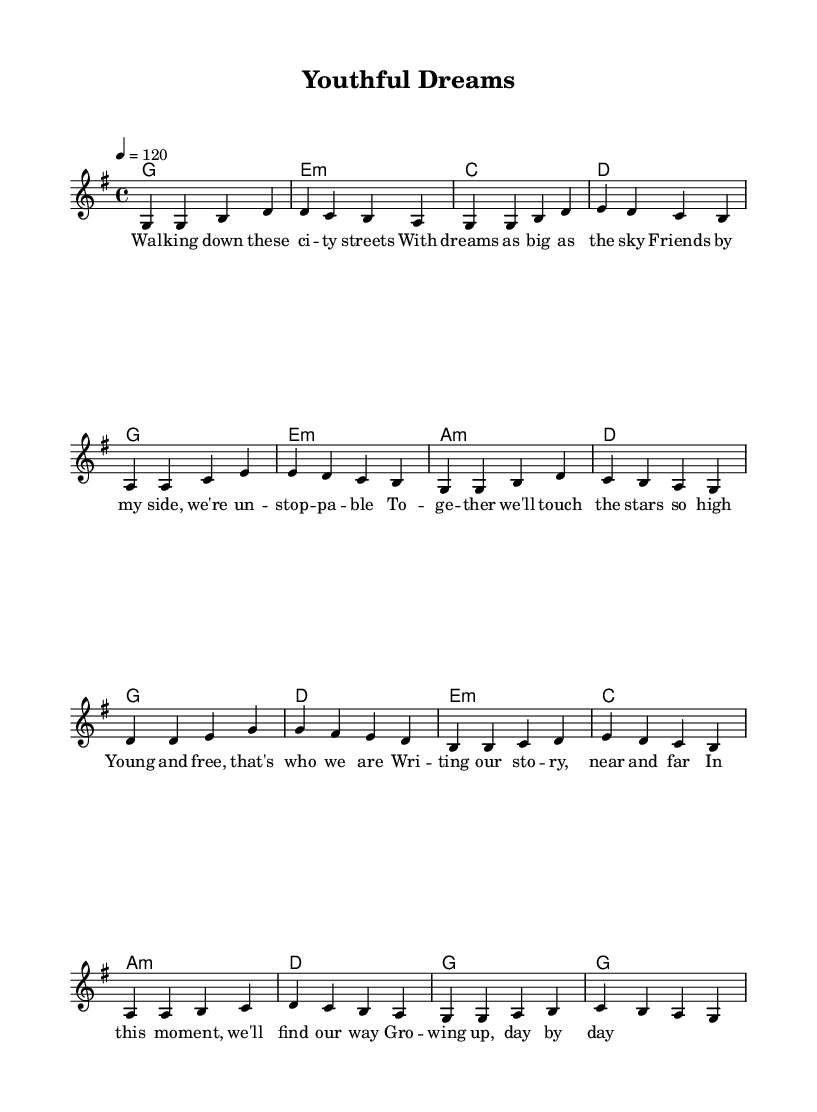What is the key signature of this music? The key signature can be found in the first measure or line of the music notation. It shows a G major key, which has one sharp (F#).
Answer: G major What is the time signature of this piece? The time signature is found at the beginning of the music score, indicating how many beats are in each measure. Here, it shows a 4 over 4, meaning there are four quarter note beats per measure.
Answer: 4/4 What is the tempo marking given for the music? The tempo marking appears in the format of beats per minute, located at the beginning of the score. In this case, it indicates a tempo of 120 beats per minute.
Answer: 120 How many measures does the verse section contain? Counting each grouping in the verse section from the music notation, there are a total of eight measures. Each set of bars represents one measure.
Answer: 8 What is the last note of the chorus melody? By looking at the melody of the chorus section, the last note can be found by identifying the final note in the line of music. Here, it shows a G note.
Answer: G How many different chords are used in the verse? By analyzing the chord sections in the score, the verse uses five different chords: G, E minor, C, D, and A minor.
Answer: 5 What musical theme is emphasized in this song? The song emphasizes themes of youth and friendship, as indicated in the lyrics that mention dreams, friends, and growing up together.
Answer: Youth and friendship 